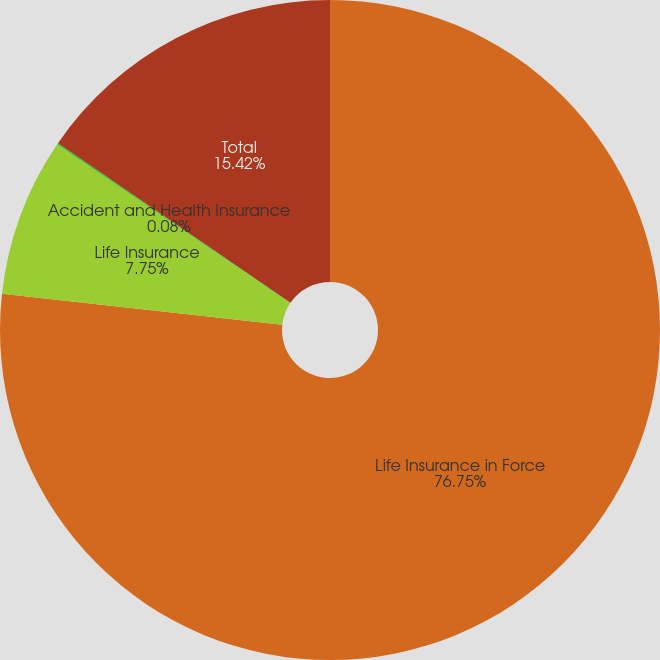Convert chart to OTSL. <chart><loc_0><loc_0><loc_500><loc_500><pie_chart><fcel>Life Insurance in Force<fcel>Life Insurance<fcel>Accident and Health Insurance<fcel>Total<nl><fcel>76.75%<fcel>7.75%<fcel>0.08%<fcel>15.42%<nl></chart> 